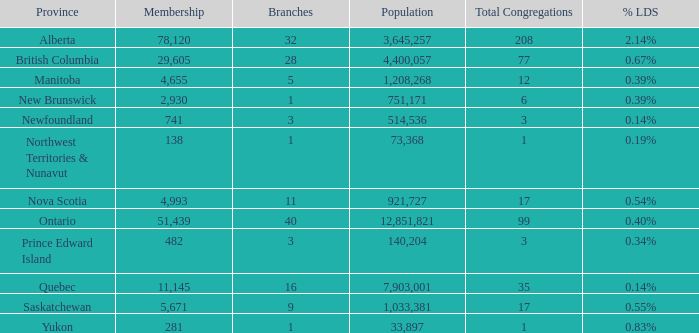What's the fewest number of branches with more than 1 total congregations, a population of 1,033,381, and a membership smaller than 5,671? None. 